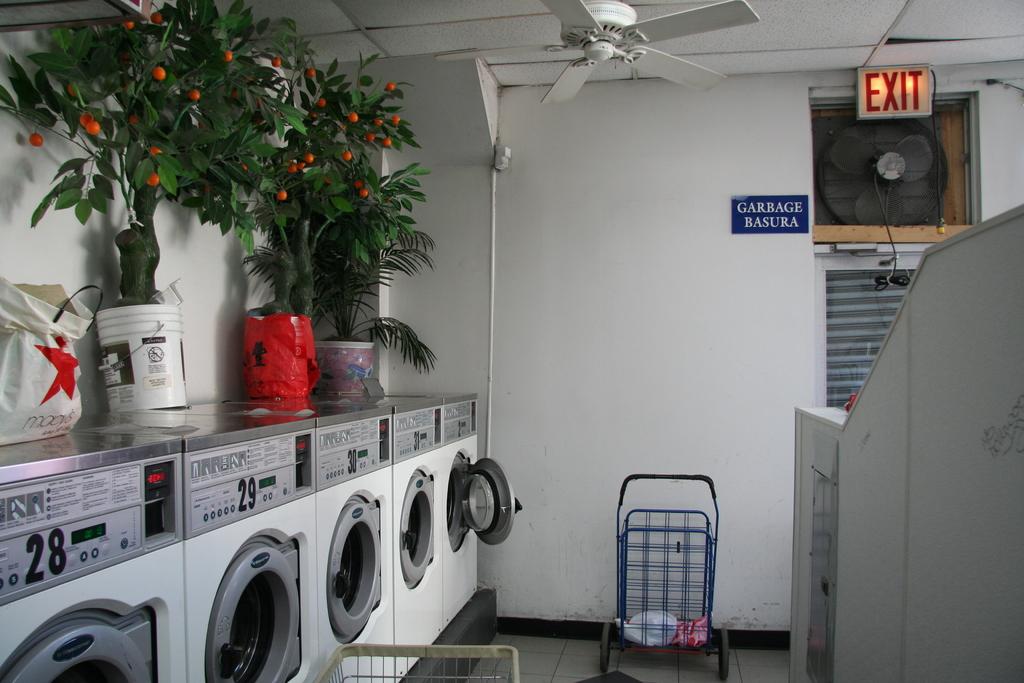What does the sign say above the fan on the right?
Make the answer very short. Exit. What does the blue sign say?
Your answer should be compact. Garbage basura. 